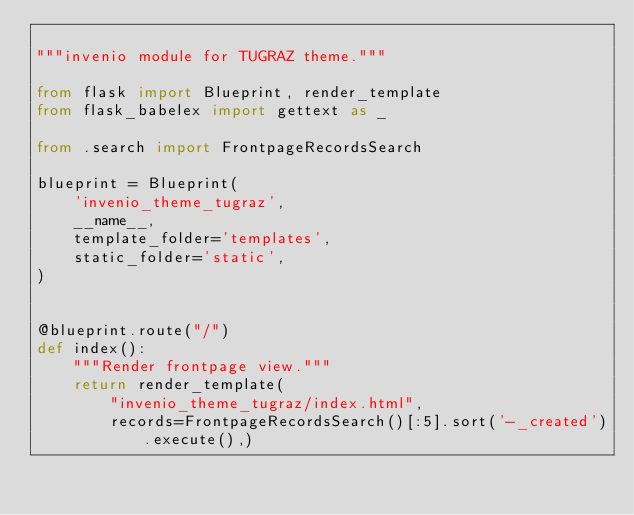<code> <loc_0><loc_0><loc_500><loc_500><_Python_>
"""invenio module for TUGRAZ theme."""

from flask import Blueprint, render_template
from flask_babelex import gettext as _

from .search import FrontpageRecordsSearch

blueprint = Blueprint(
    'invenio_theme_tugraz',
    __name__,
    template_folder='templates',
    static_folder='static',
)


@blueprint.route("/")
def index():
    """Render frontpage view."""
    return render_template(
        "invenio_theme_tugraz/index.html",
        records=FrontpageRecordsSearch()[:5].sort('-_created').execute(),)
</code> 